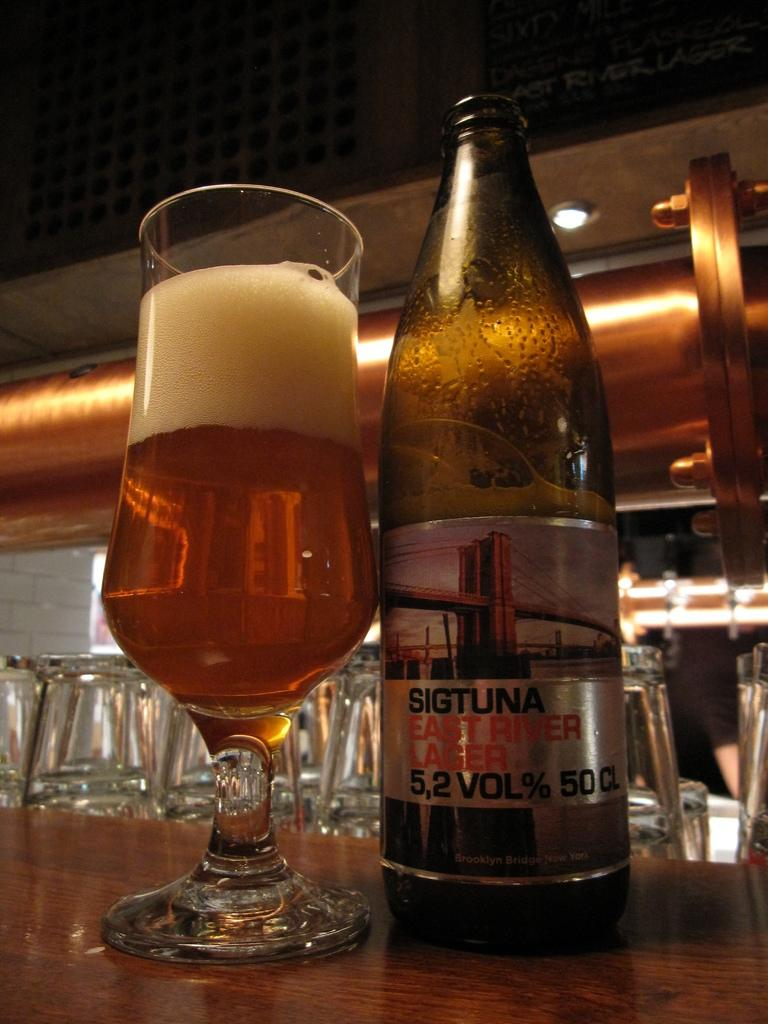What piece of furniture is present in the image? There is a table in the image. What is placed on the table? There is a bottle and a glass of drink on the table. Are there any other glasses visible in the image? Yes, there are glasses visible in the background of the image. Can you describe the source of light in the image? There is a light in the image. What type of field can be seen in the image? There is no field present in the image; it features a table with a bottle and a glass of drink, glasses in the background, and a light source. What kind of meal is being prepared in the image? There is no meal preparation visible in the image; it only shows a table with a bottle and a glass of drink, glasses in the background, and a light source. 